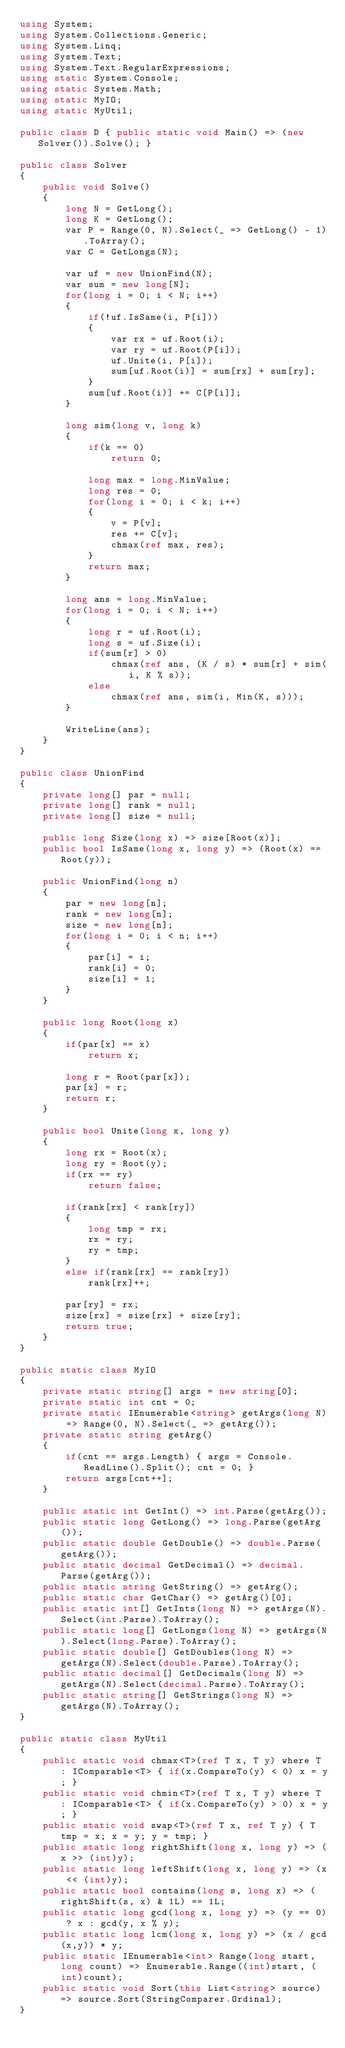Convert code to text. <code><loc_0><loc_0><loc_500><loc_500><_C#_>using System;
using System.Collections.Generic;
using System.Linq;
using System.Text;
using System.Text.RegularExpressions;
using static System.Console;
using static System.Math;
using static MyIO;
using static MyUtil;

public class D { public static void Main() => (new Solver()).Solve(); }

public class Solver
{
	public void Solve()
	{
		long N = GetLong();
		long K = GetLong();
		var P = Range(0, N).Select(_ => GetLong() - 1).ToArray();
		var C = GetLongs(N);

		var uf = new UnionFind(N);
		var sum = new long[N];
		for(long i = 0; i < N; i++)
		{
			if(!uf.IsSame(i, P[i]))
			{
				var rx = uf.Root(i);
				var ry = uf.Root(P[i]);
				uf.Unite(i, P[i]);
				sum[uf.Root(i)] = sum[rx] + sum[ry];
			}
			sum[uf.Root(i)] += C[P[i]];
		}

		long sim(long v, long k)
		{
			if(k == 0)
				return 0;
				
			long max = long.MinValue;
			long res = 0;
			for(long i = 0; i < k; i++)
			{
				v = P[v];
				res += C[v];
				chmax(ref max, res);
			}
			return max;
		}

		long ans = long.MinValue;
		for(long i = 0; i < N; i++)
		{
			long r = uf.Root(i);
			long s = uf.Size(i);
			if(sum[r] > 0)
				chmax(ref ans, (K / s) * sum[r] + sim(i, K % s));
			else
				chmax(ref ans, sim(i, Min(K, s)));
		}

		WriteLine(ans);
	}
}

public class UnionFind
{
	private long[] par = null;
	private long[] rank = null;
	private long[] size = null;
	
	public long Size(long x) => size[Root(x)];
	public bool IsSame(long x, long y) => (Root(x) == Root(y));

	public UnionFind(long n)
	{
		par = new long[n];
		rank = new long[n];
		size = new long[n];
		for(long i = 0; i < n; i++)
		{
			par[i] = i;
			rank[i] = 0;
			size[i] = 1;
		}
	}

	public long Root(long x)
	{
		if(par[x] == x)
			return x;

		long r = Root(par[x]);
		par[x] = r;
		return r;
	}
	
	public bool Unite(long x, long y)
	{
		long rx = Root(x);
		long ry = Root(y);
		if(rx == ry)
			return false;
		
		if(rank[rx] < rank[ry])
		{
			long tmp = rx;
			rx = ry;
			ry = tmp;
		}
		else if(rank[rx] == rank[ry])
			rank[rx]++;

		par[ry] = rx;
		size[rx] = size[rx] + size[ry];
		return true;
	}
}

public static class MyIO
{
	private static string[] args = new string[0];
	private static int cnt = 0;
	private static IEnumerable<string> getArgs(long N) => Range(0, N).Select(_ => getArg());
	private static string getArg()
	{
		if(cnt == args.Length) { args = Console.ReadLine().Split(); cnt = 0; }
		return args[cnt++];
	}

	public static int GetInt() => int.Parse(getArg());
	public static long GetLong() => long.Parse(getArg());
	public static double GetDouble() => double.Parse(getArg());
	public static decimal GetDecimal() => decimal.Parse(getArg());
	public static string GetString() => getArg();
	public static char GetChar() => getArg()[0];
	public static int[] GetInts(long N) => getArgs(N).Select(int.Parse).ToArray();
	public static long[] GetLongs(long N) => getArgs(N).Select(long.Parse).ToArray();
	public static double[] GetDoubles(long N) => getArgs(N).Select(double.Parse).ToArray();
	public static decimal[] GetDecimals(long N) => getArgs(N).Select(decimal.Parse).ToArray();
	public static string[] GetStrings(long N) => getArgs(N).ToArray();
}

public static class MyUtil
{
	public static void chmax<T>(ref T x, T y) where T : IComparable<T> { if(x.CompareTo(y) < 0) x = y; }
	public static void chmin<T>(ref T x, T y) where T : IComparable<T> { if(x.CompareTo(y) > 0)	x = y; }
	public static void swap<T>(ref T x, ref T y) { T tmp = x; x = y; y = tmp; }
	public static long rightShift(long x, long y) => (x >> (int)y);
	public static long leftShift(long x, long y) => (x << (int)y);
	public static bool contains(long s, long x) => (rightShift(s, x) & 1L) == 1L;
	public static long gcd(long x, long y) => (y == 0) ? x : gcd(y, x % y);
	public static long lcm(long x, long y) => (x / gcd(x,y)) * y;	
	public static IEnumerable<int> Range(long start, long count) => Enumerable.Range((int)start, (int)count);
	public static void Sort(this List<string> source) => source.Sort(StringComparer.Ordinal);
}
</code> 